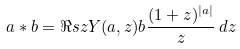<formula> <loc_0><loc_0><loc_500><loc_500>a * b = \Re s z Y ( a , z ) b \frac { ( 1 + z ) ^ { | a | } } { z } \, d z</formula> 